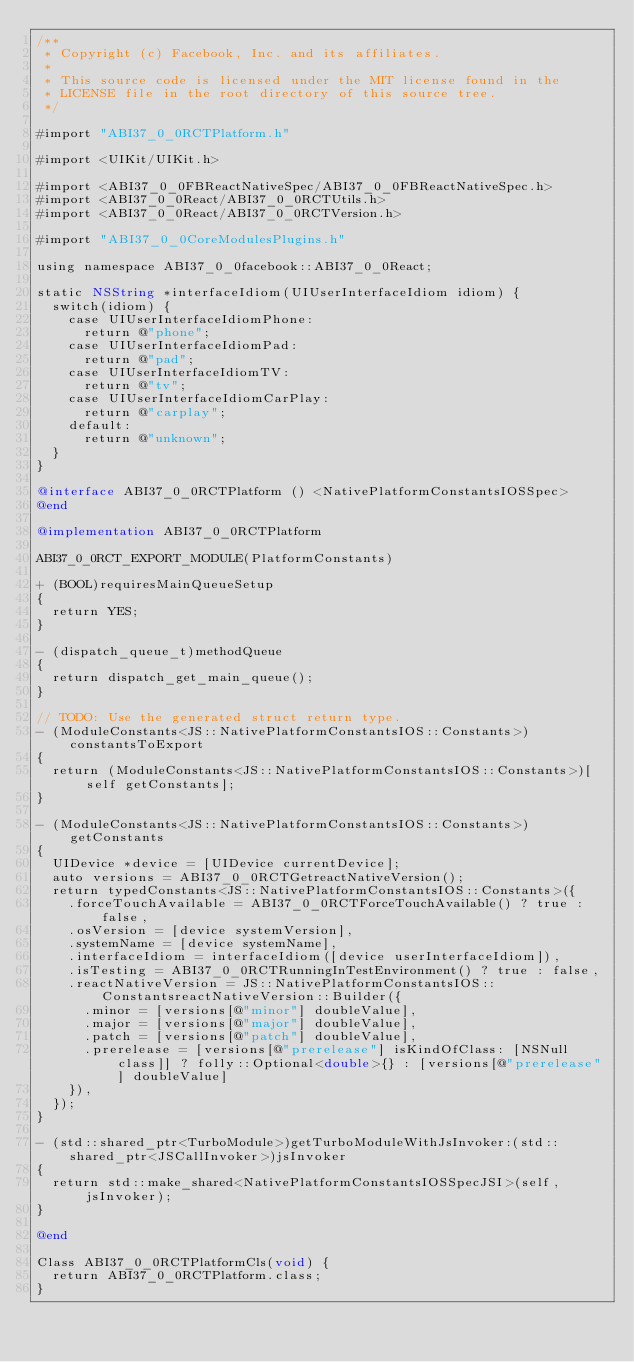Convert code to text. <code><loc_0><loc_0><loc_500><loc_500><_ObjectiveC_>/**
 * Copyright (c) Facebook, Inc. and its affiliates.
 *
 * This source code is licensed under the MIT license found in the
 * LICENSE file in the root directory of this source tree.
 */

#import "ABI37_0_0RCTPlatform.h"

#import <UIKit/UIKit.h>

#import <ABI37_0_0FBReactNativeSpec/ABI37_0_0FBReactNativeSpec.h>
#import <ABI37_0_0React/ABI37_0_0RCTUtils.h>
#import <ABI37_0_0React/ABI37_0_0RCTVersion.h>

#import "ABI37_0_0CoreModulesPlugins.h"

using namespace ABI37_0_0facebook::ABI37_0_0React;

static NSString *interfaceIdiom(UIUserInterfaceIdiom idiom) {
  switch(idiom) {
    case UIUserInterfaceIdiomPhone:
      return @"phone";
    case UIUserInterfaceIdiomPad:
      return @"pad";
    case UIUserInterfaceIdiomTV:
      return @"tv";
    case UIUserInterfaceIdiomCarPlay:
      return @"carplay";
    default:
      return @"unknown";
  }
}

@interface ABI37_0_0RCTPlatform () <NativePlatformConstantsIOSSpec>
@end

@implementation ABI37_0_0RCTPlatform

ABI37_0_0RCT_EXPORT_MODULE(PlatformConstants)

+ (BOOL)requiresMainQueueSetup
{
  return YES;
}

- (dispatch_queue_t)methodQueue
{
  return dispatch_get_main_queue();
}

// TODO: Use the generated struct return type.
- (ModuleConstants<JS::NativePlatformConstantsIOS::Constants>)constantsToExport
{
  return (ModuleConstants<JS::NativePlatformConstantsIOS::Constants>)[self getConstants];
}

- (ModuleConstants<JS::NativePlatformConstantsIOS::Constants>)getConstants
{
  UIDevice *device = [UIDevice currentDevice];
  auto versions = ABI37_0_0RCTGetreactNativeVersion();
  return typedConstants<JS::NativePlatformConstantsIOS::Constants>({
    .forceTouchAvailable = ABI37_0_0RCTForceTouchAvailable() ? true : false,
    .osVersion = [device systemVersion],
    .systemName = [device systemName],
    .interfaceIdiom = interfaceIdiom([device userInterfaceIdiom]),
    .isTesting = ABI37_0_0RCTRunningInTestEnvironment() ? true : false,
    .reactNativeVersion = JS::NativePlatformConstantsIOS::ConstantsreactNativeVersion::Builder({
      .minor = [versions[@"minor"] doubleValue],
      .major = [versions[@"major"] doubleValue],
      .patch = [versions[@"patch"] doubleValue],
      .prerelease = [versions[@"prerelease"] isKindOfClass: [NSNull class]] ? folly::Optional<double>{} : [versions[@"prerelease"] doubleValue]
    }),
  });
}

- (std::shared_ptr<TurboModule>)getTurboModuleWithJsInvoker:(std::shared_ptr<JSCallInvoker>)jsInvoker
{
  return std::make_shared<NativePlatformConstantsIOSSpecJSI>(self, jsInvoker);
}

@end

Class ABI37_0_0RCTPlatformCls(void) {
  return ABI37_0_0RCTPlatform.class;
}
</code> 